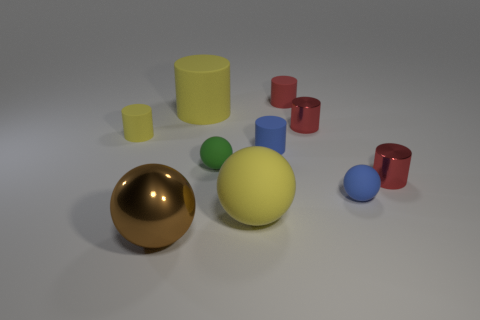Subtract all red cylinders. How many were subtracted if there are1red cylinders left? 2 Subtract all large yellow cylinders. How many cylinders are left? 5 Subtract all brown spheres. How many spheres are left? 3 Subtract all balls. How many objects are left? 6 Subtract all yellow blocks. How many red cylinders are left? 3 Add 3 big yellow matte cylinders. How many big yellow matte cylinders are left? 4 Add 6 red cubes. How many red cubes exist? 6 Subtract 0 brown cylinders. How many objects are left? 10 Subtract 5 cylinders. How many cylinders are left? 1 Subtract all blue balls. Subtract all gray cylinders. How many balls are left? 3 